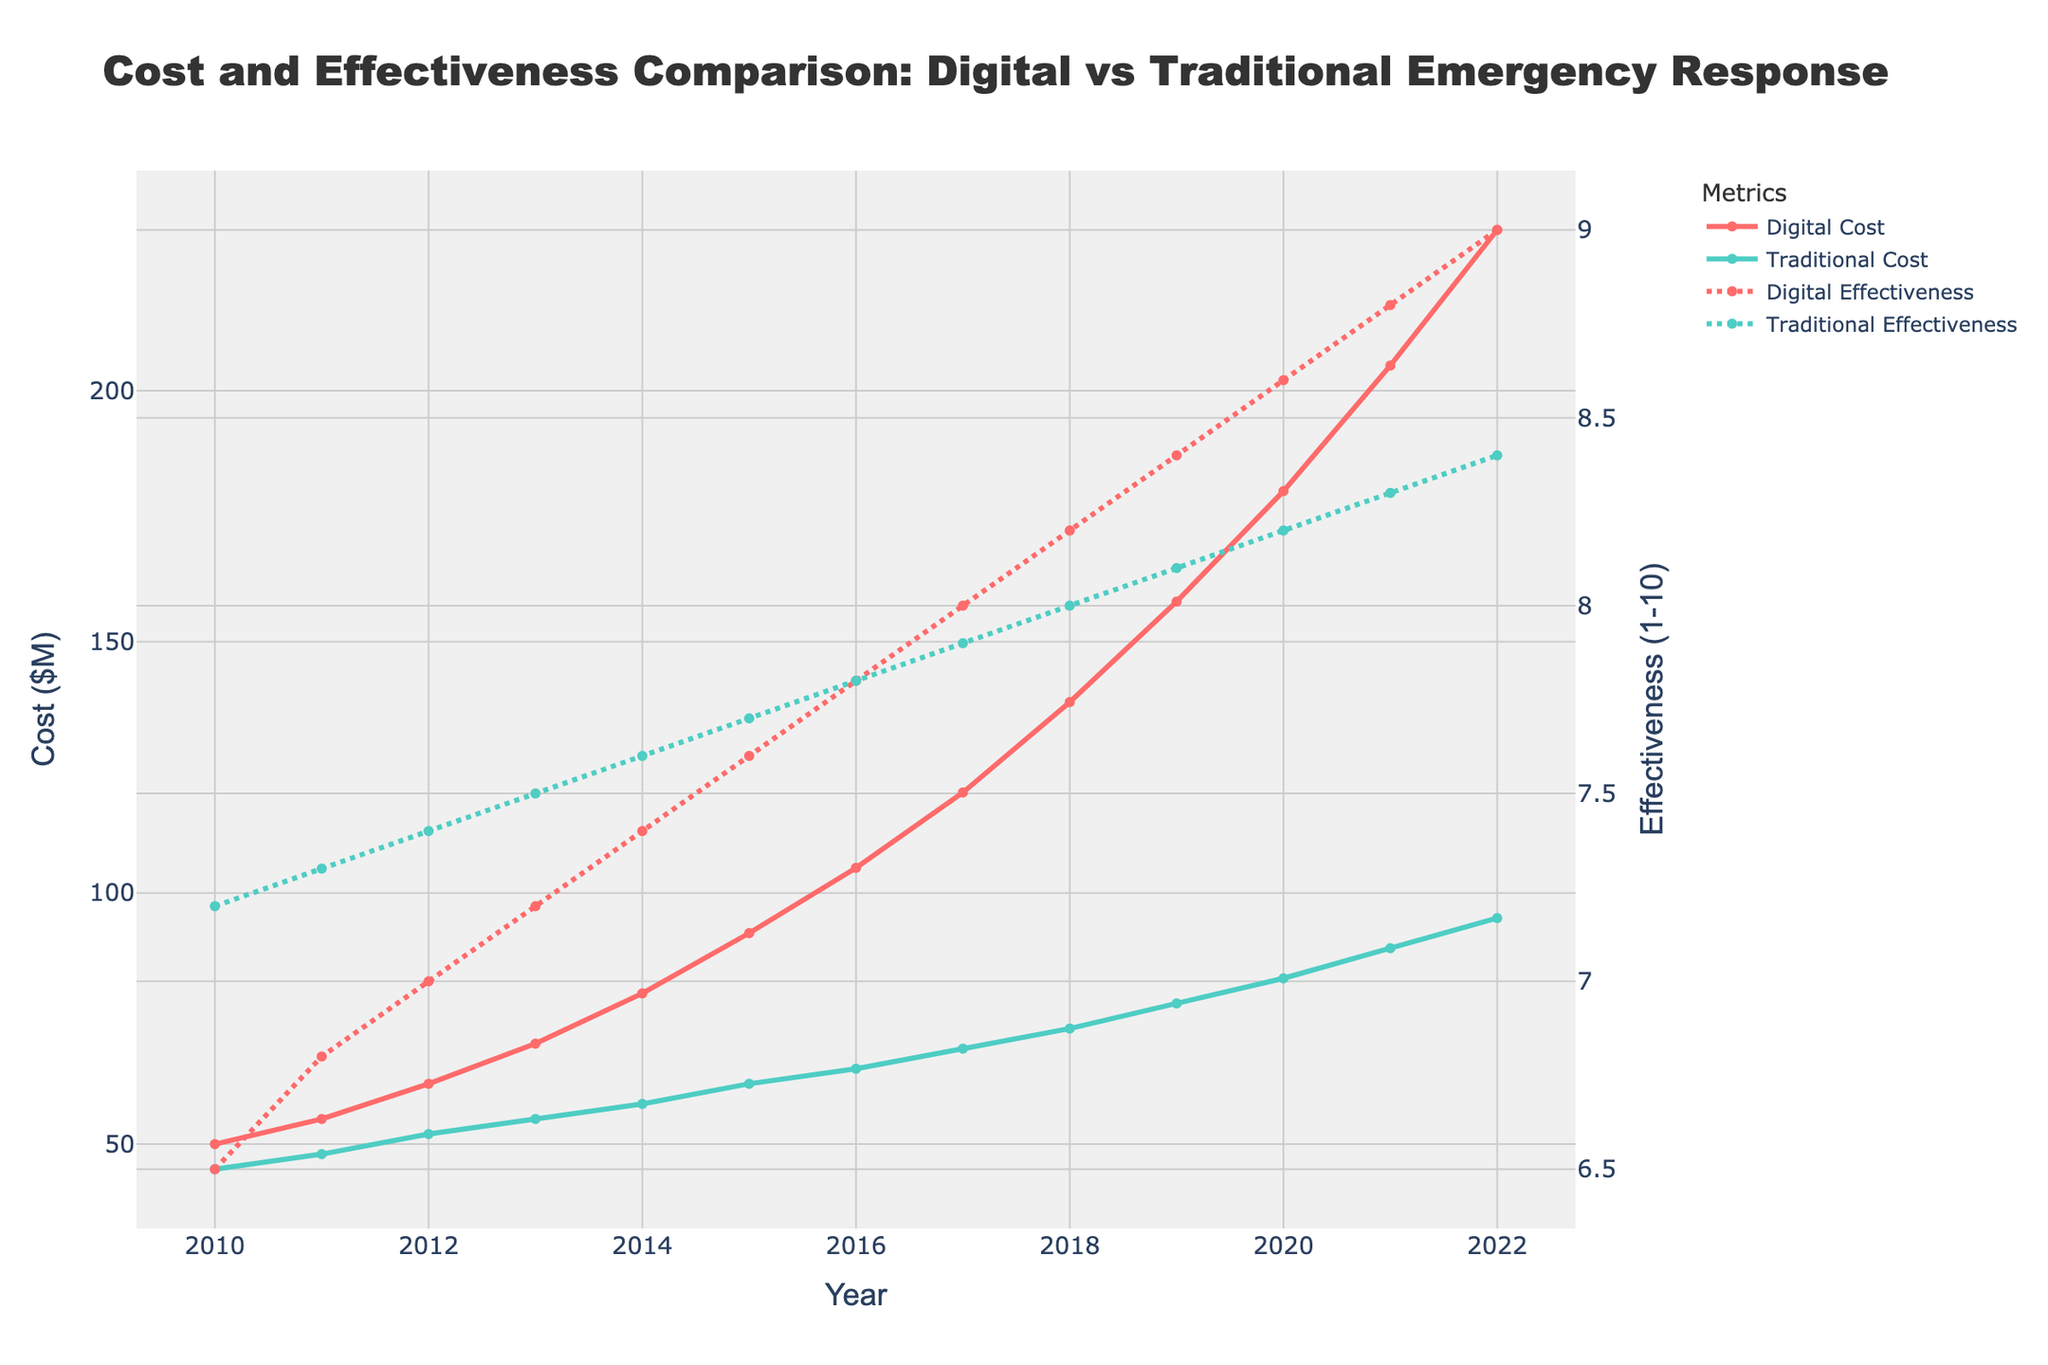Which year did the digital emergency response cost exceed the traditional emergency response cost by more than $70M? To solve this, look for the difference between red and green lines in each year. In 2021, the digital cost is $205M and the traditional cost is $89M. The difference is $205M - $89M = $116M, which is more than $70M.
Answer: 2021 Between 2010 and 2022, what is the average increase per year in the digital emergency response cost? Calculate the total increase over the period (232M - 50M = 182M) and divide by the number of years (2022 - 2010 = 12). So, 182M / 12 ≈ 15.2M per year.
Answer: 15.2M Which year shows the highest effectiveness for digital emergency response? Look for the year where the red dashed line reaches its peak. In 2022, the digital response effectiveness is at 9.0, the highest value.
Answer: 2022 In 2017, how much more effective was the digital response compared to the traditional response? In 2017, compare the red and green dashed lines: digital effectiveness is 8.0 and traditional is 7.9. The difference is 8.0 - 7.9 = 0.1.
Answer: 0.1 What is the total cost for digital emergency responses over the period 2010-2022? Sum the values of the red line from 2010 to 2022: 50 + 55 + 62 + 70 + 80 + 92 + 105 + 120 + 138 + 158 + 180 + 205 + 232 = 1547M.
Answer: 1547M Compare the effectiveness trends of digital and traditional methods from 2010 to 2022. Observe the slopes of dashed red and green lines. The digital effectiveness shows a steady increase from 6.5 to 9.0, while the traditional effectiveness shows a mild increase from 7.2 to 8.4. The digital trend is steeper.
Answer: Digital effectiveness increased more sharply than traditional What is the year-on-year percentage increase in traditional emergency response cost from 2019 to 2020? Calculate the percentage increase: ((83 - 78) / 78) * 100 = (5 / 78) * 100 ≈ 6.41%.
Answer: 6.41% What is the total effectiveness score for traditional responses over the period 2010-2022? Sum the values of the green dashed line from 2010 to 2022: 7.2 + 7.3 + 7.4 + 7.5 + 7.6 + 7.7 + 7.8 + 7.9 + 8.0 + 8.1 + 8.2 + 8.3 + 8.4 = 101.4.
Answer: 101.4 